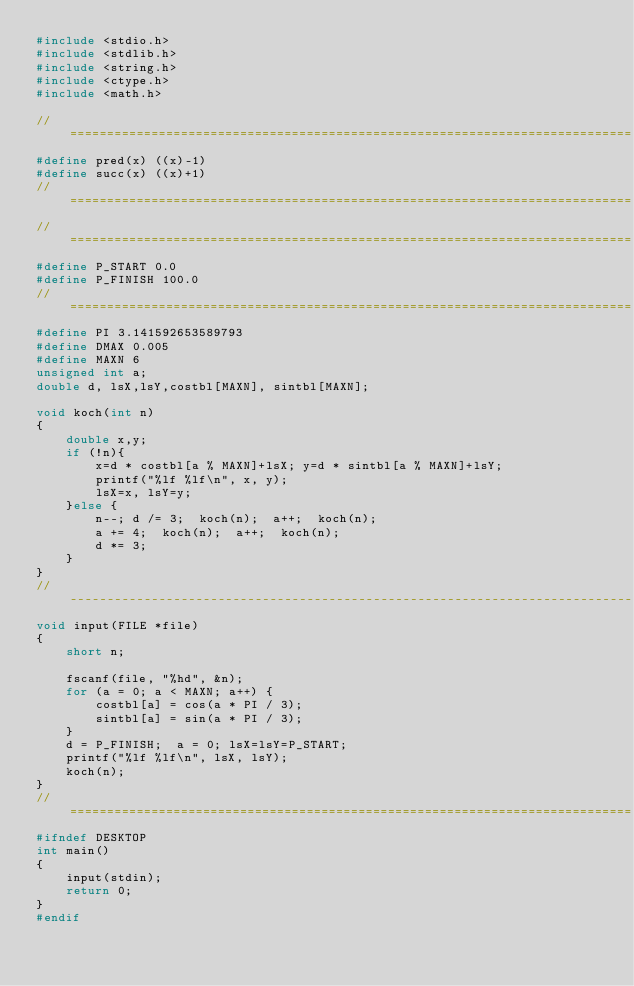Convert code to text. <code><loc_0><loc_0><loc_500><loc_500><_C_>#include <stdio.h>
#include <stdlib.h>
#include <string.h>
#include <ctype.h>
#include <math.h>
 
//============================================================================
#define pred(x) ((x)-1)
#define succ(x) ((x)+1)
//============================================================================
//============================================================================
#define P_START 0.0
#define P_FINISH 100.0
//============================================================================
#define PI 3.141592653589793
#define DMAX 0.005
#define MAXN 6
unsigned int a;
double d, lsX,lsY,costbl[MAXN], sintbl[MAXN];
 
void koch(int n)
{
    double x,y;
    if (!n){
        x=d * costbl[a % MAXN]+lsX; y=d * sintbl[a % MAXN]+lsY;
        printf("%lf %lf\n", x, y);
        lsX=x, lsY=y;
    }else {
        n--; d /= 3;  koch(n);  a++;  koch(n);
        a += 4;  koch(n);  a++;  koch(n);
        d *= 3;
    }
}
//----------------------------------------------------------------------------
void input(FILE *file)
{
    short n;
 
    fscanf(file, "%hd", &n);
    for (a = 0; a < MAXN; a++) {
        costbl[a] = cos(a * PI / 3);
        sintbl[a] = sin(a * PI / 3);
    }
    d = P_FINISH;  a = 0; lsX=lsY=P_START;
    printf("%lf %lf\n", lsX, lsY);
    koch(n);
}
//============================================================================
#ifndef DESKTOP
int main()
{
    input(stdin);
    return 0;
}
#endif</code> 